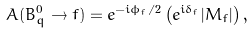<formula> <loc_0><loc_0><loc_500><loc_500>A ( B _ { q } ^ { 0 } \to f ) = e ^ { - i \phi _ { f } / 2 } \left ( e ^ { i \delta _ { f } } | M _ { f } | \right ) ,</formula> 